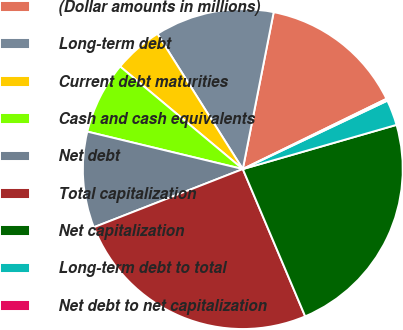Convert chart. <chart><loc_0><loc_0><loc_500><loc_500><pie_chart><fcel>(Dollar amounts in millions)<fcel>Long-term debt<fcel>Current debt maturities<fcel>Cash and cash equivalents<fcel>Net debt<fcel>Total capitalization<fcel>Net capitalization<fcel>Long-term debt to total<fcel>Net debt to net capitalization<nl><fcel>14.67%<fcel>12.06%<fcel>4.95%<fcel>7.32%<fcel>9.69%<fcel>25.45%<fcel>23.08%<fcel>2.58%<fcel>0.2%<nl></chart> 